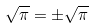<formula> <loc_0><loc_0><loc_500><loc_500>\sqrt { \pi } = \pm \sqrt { \pi }</formula> 